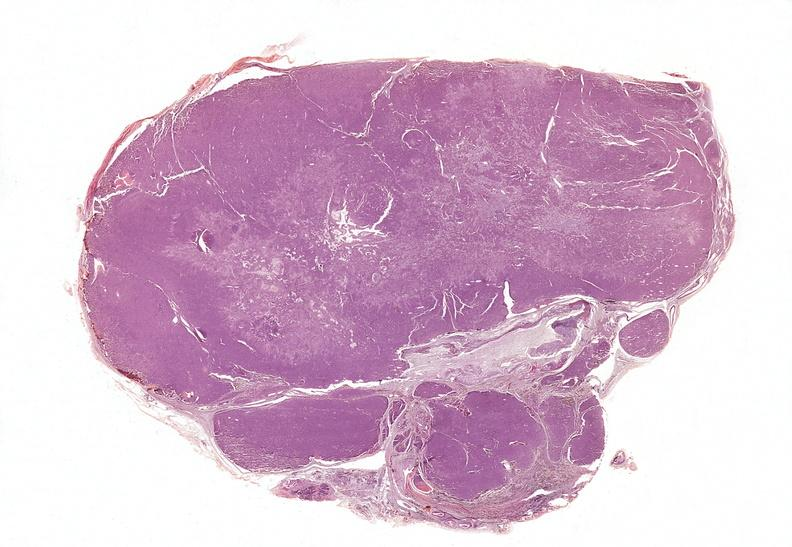where is this part in the figure?
Answer the question using a single word or phrase. Endocrine system 